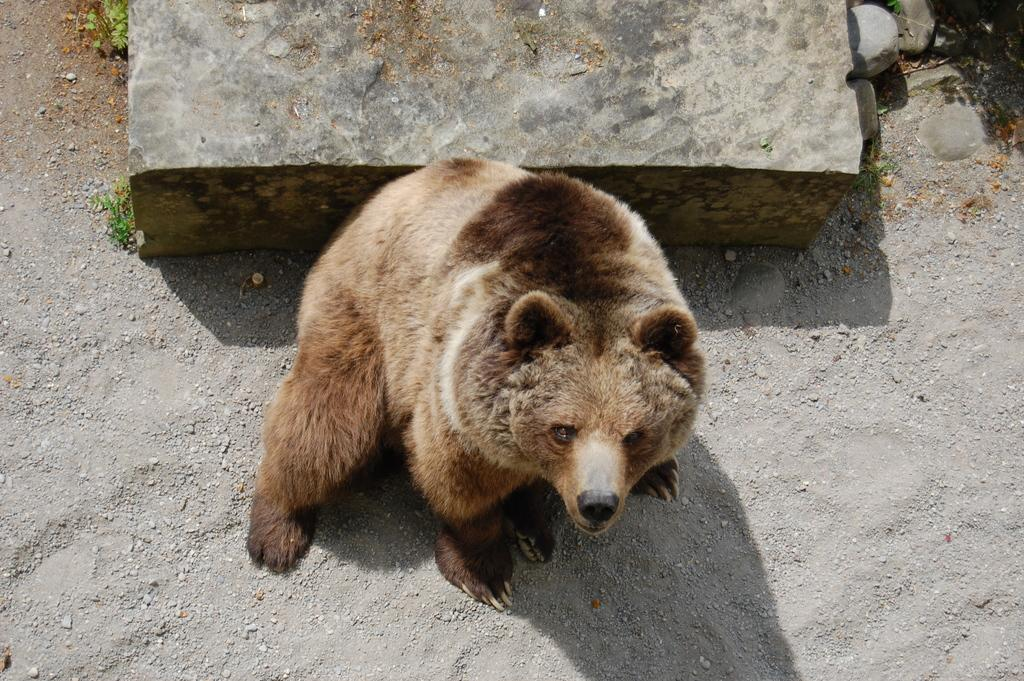What type of living creature is in the image? There is an animal in the image. What can be seen on the left side of the image? There are plants on the left side of the image. What type of inanimate objects are present in the image? There are stones in the image. What type of toy can be seen being distributed in the image? There is no toy or distribution activity present in the image. 